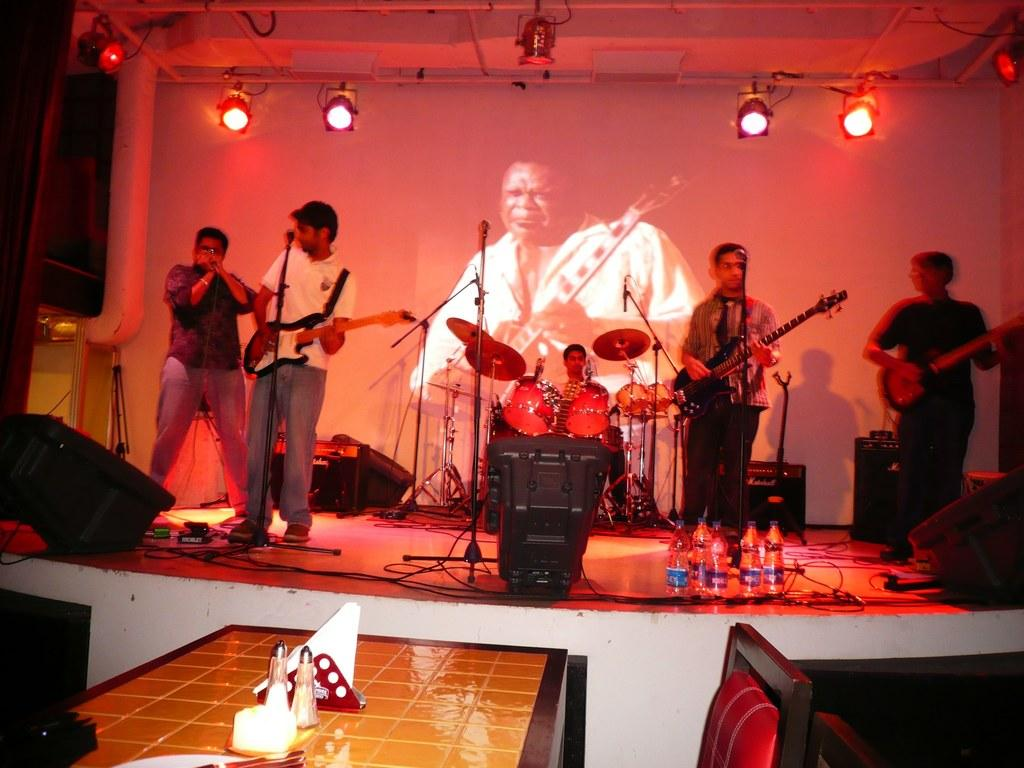How many people are present in the image? There are five people in the image. Where are the people located in the image? The people are standing on a stage. What are the people doing on the stage? The people are playing musical instruments. What equipment is present in front of the stage? There are speakers, lights, and bottles in front of the stage. Can you see a bear playing with a lock and balls in the image? No, there is no bear or any objects related to your question in the image. 